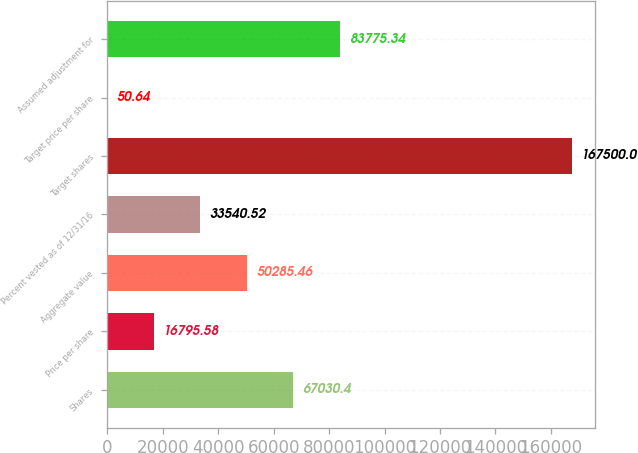Convert chart to OTSL. <chart><loc_0><loc_0><loc_500><loc_500><bar_chart><fcel>Shares<fcel>Price per share<fcel>Aggregate value<fcel>Percent vested as of 12/31/16<fcel>Target shares<fcel>Target price per share<fcel>Assumed adjustment for<nl><fcel>67030.4<fcel>16795.6<fcel>50285.5<fcel>33540.5<fcel>167500<fcel>50.64<fcel>83775.3<nl></chart> 